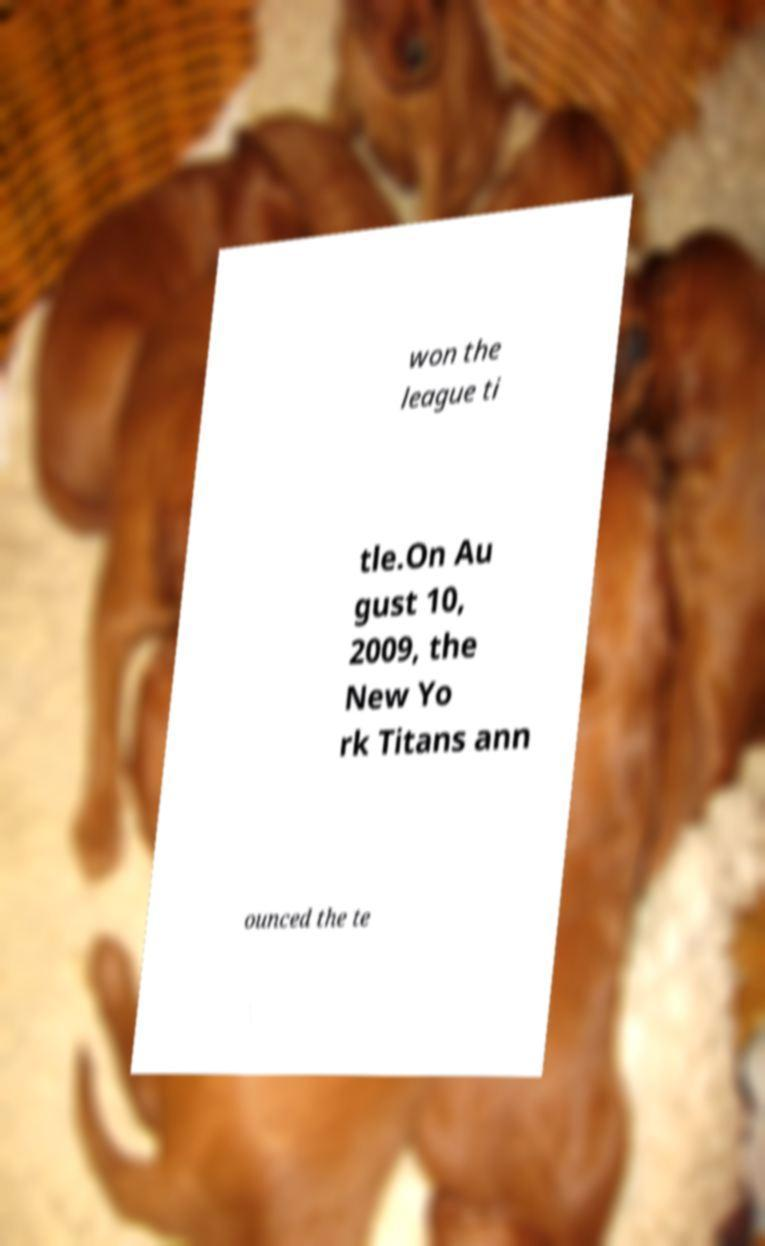For documentation purposes, I need the text within this image transcribed. Could you provide that? won the league ti tle.On Au gust 10, 2009, the New Yo rk Titans ann ounced the te 